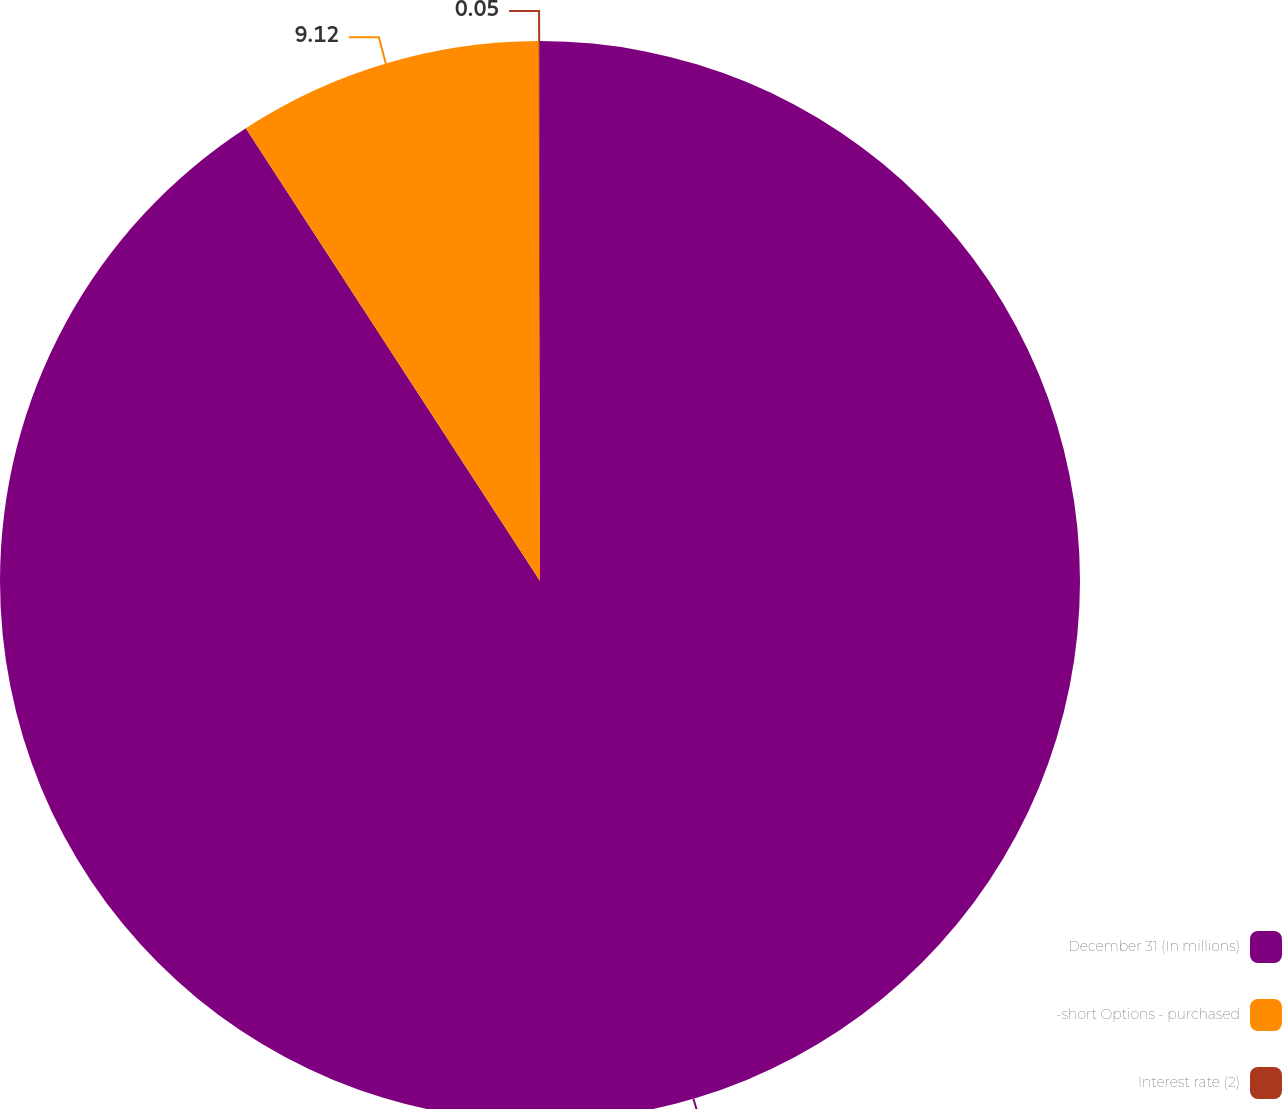<chart> <loc_0><loc_0><loc_500><loc_500><pie_chart><fcel>December 31 (In millions)<fcel>-short Options - purchased<fcel>Interest rate (2)<nl><fcel>90.83%<fcel>9.12%<fcel>0.05%<nl></chart> 